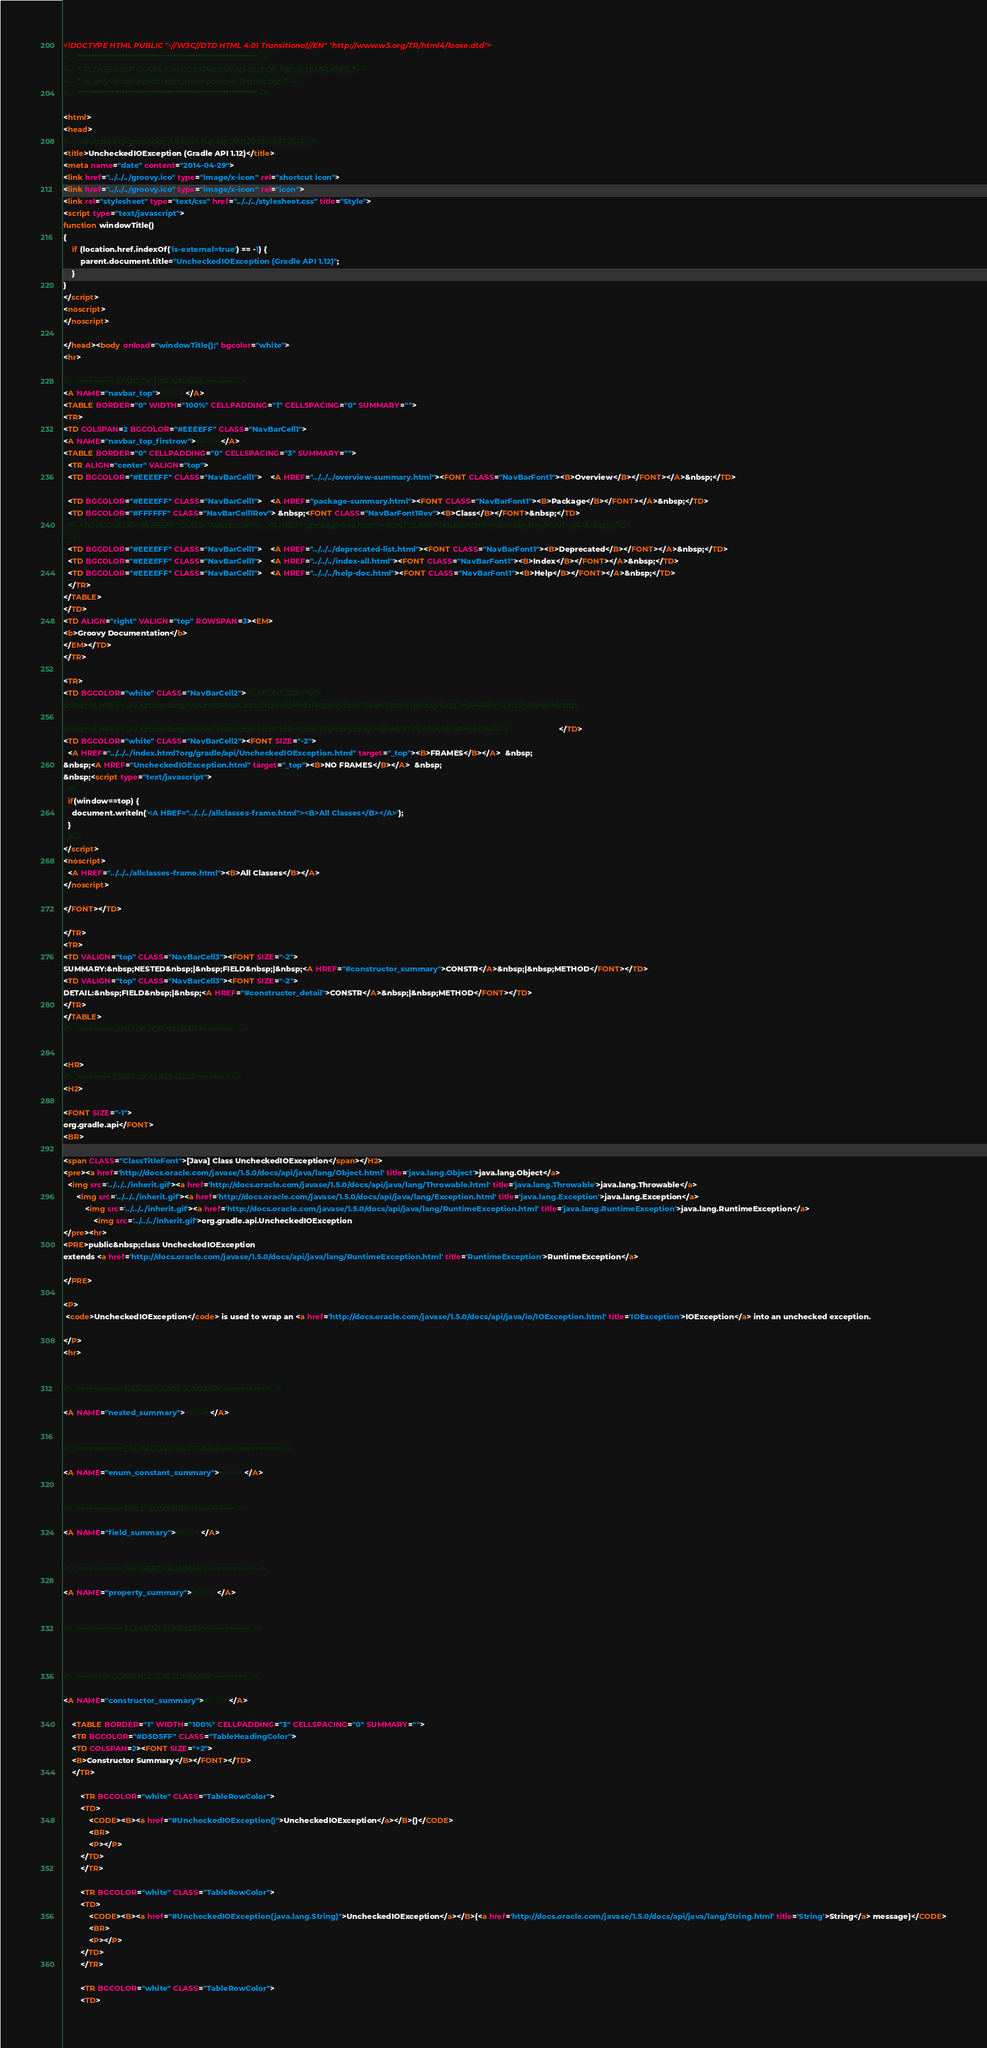<code> <loc_0><loc_0><loc_500><loc_500><_HTML_><!DOCTYPE HTML PUBLIC "-//W3C//DTD HTML 4.01 Transitional//EN" "http://www.w3.org/TR/html4/loose.dtd">
<!-- **************************************************************** -->
<!-- *  PLEASE KEEP COMPLICATED EXPRESSIONS OUT OF THESE TEMPLATES, * -->
<!-- *  i.e. only iterate & print data where possible. Thanks, Jez. * -->
<!-- **************************************************************** -->

<html>
<head>
<!-- Generated by groovydoc (1.8.6) on Tue Apr 29 11:29:28 CEST 2014 -->
<title>UncheckedIOException (Gradle API 1.12)</title>
<meta name="date" content="2014-04-29">
<link href="../../../groovy.ico" type="image/x-icon" rel="shortcut icon">
<link href="../../../groovy.ico" type="image/x-icon" rel="icon">
<link rel="stylesheet" type="text/css" href="../../../stylesheet.css" title="Style">
<script type="text/javascript">
function windowTitle()
{
    if (location.href.indexOf('is-external=true') == -1) {
        parent.document.title="UncheckedIOException (Gradle API 1.12)";
    }
}
</script>
<noscript>
</noscript>

</head><body onload="windowTitle();" bgcolor="white">
<hr>

<!-- ========= START OF TOP NAVBAR ======= -->
<A NAME="navbar_top"><!-- --></A>
<TABLE BORDER="0" WIDTH="100%" CELLPADDING="1" CELLSPACING="0" SUMMARY="">
<TR>
<TD COLSPAN=2 BGCOLOR="#EEEEFF" CLASS="NavBarCell1">
<A NAME="navbar_top_firstrow"><!-- --></A>
<TABLE BORDER="0" CELLPADDING="0" CELLSPACING="3" SUMMARY="">
  <TR ALIGN="center" VALIGN="top">
  <TD BGCOLOR="#EEEEFF" CLASS="NavBarCell1">    <A HREF="../../../overview-summary.html"><FONT CLASS="NavBarFont1"><B>Overview</B></FONT></A>&nbsp;</TD>

  <TD BGCOLOR="#EEEEFF" CLASS="NavBarCell1">    <A HREF="package-summary.html"><FONT CLASS="NavBarFont1"><B>Package</B></FONT></A>&nbsp;</TD>
  <TD BGCOLOR="#FFFFFF" CLASS="NavBarCell1Rev"> &nbsp;<FONT CLASS="NavBarFont1Rev"><B>Class</B></FONT>&nbsp;</TD>
  <!--<TD BGCOLOR="#EEEEFF" CLASS="NavBarCell1">    <A HREF="package-tree.html"><FONT CLASS="NavBarFont1"><B>Tree</B></FONT></A>&nbsp;</TD>
  -->
  <TD BGCOLOR="#EEEEFF" CLASS="NavBarCell1">    <A HREF="../../../deprecated-list.html"><FONT CLASS="NavBarFont1"><B>Deprecated</B></FONT></A>&nbsp;</TD>
  <TD BGCOLOR="#EEEEFF" CLASS="NavBarCell1">    <A HREF="../../../index-all.html"><FONT CLASS="NavBarFont1"><B>Index</B></FONT></A>&nbsp;</TD>
  <TD BGCOLOR="#EEEEFF" CLASS="NavBarCell1">    <A HREF="../../../help-doc.html"><FONT CLASS="NavBarFont1"><B>Help</B></FONT></A>&nbsp;</TD>
  </TR>
</TABLE>
</TD>
<TD ALIGN="right" VALIGN="top" ROWSPAN=3><EM>
<b>Groovy Documentation</b>
</EM></TD>
</TR>

<TR>
<TD BGCOLOR="white" CLASS="NavBarCell2"><!--<FONT SIZE="-2">
&nbsp;<A HREF="../../../groovy/lang/ExpandoMetaClass.ExpandoMetaProperty.html" title="class in groovy.lang"><B>PREV CLASS</B></A>&nbsp;

&nbsp;<A HREF="../../../groovy/lang/GroovyClassLoader.html" title="class in groovy.lang"><B>NEXT CLASS</B></A></FONT>--></TD>
<TD BGCOLOR="white" CLASS="NavBarCell2"><FONT SIZE="-2">
  <A HREF="../../../index.html?org/gradle/api/UncheckedIOException.html" target="_top"><B>FRAMES</B></A>  &nbsp;
&nbsp;<A HREF="UncheckedIOException.html" target="_top"><B>NO FRAMES</B></A>  &nbsp;
&nbsp;<script type="text/javascript">
  <!--
  if(window==top) {
    document.writeln('<A HREF="../../../allclasses-frame.html"><B>All Classes</B></A>');
  }
  //-->
</script>
<noscript>
  <A HREF="../../../allclasses-frame.html"><B>All Classes</B></A>
</noscript>

</FONT></TD>

</TR>
<TR>
<TD VALIGN="top" CLASS="NavBarCell3"><FONT SIZE="-2">
SUMMARY:&nbsp;NESTED&nbsp;|&nbsp;FIELD&nbsp;|&nbsp;<A HREF="#constructor_summary">CONSTR</A>&nbsp;|&nbsp;METHOD</FONT></TD>
<TD VALIGN="top" CLASS="NavBarCell3"><FONT SIZE="-2">
DETAIL:&nbsp;FIELD&nbsp;|&nbsp;<A HREF="#constructor_detail">CONSTR</A>&nbsp;|&nbsp;METHOD</FONT></TD>
</TR>
</TABLE>
<!-- ========= END OF TOP NAVBAR ========= -->


<HR>
<!-- ======== START OF CLASS DATA ======== -->
<H2>

<FONT SIZE="-1">
org.gradle.api</FONT>
<BR>

<span CLASS="ClassTitleFont">[Java] Class UncheckedIOException</span></H2>
<pre><a href='http://docs.oracle.com/javase/1.5.0/docs/api/java/lang/Object.html' title='java.lang.Object'>java.lang.Object</a>
  <img src='../../../inherit.gif'><a href='http://docs.oracle.com/javase/1.5.0/docs/api/java/lang/Throwable.html' title='java.lang.Throwable'>java.lang.Throwable</a>
      <img src='../../../inherit.gif'><a href='http://docs.oracle.com/javase/1.5.0/docs/api/java/lang/Exception.html' title='java.lang.Exception'>java.lang.Exception</a>
          <img src='../../../inherit.gif'><a href='http://docs.oracle.com/javase/1.5.0/docs/api/java/lang/RuntimeException.html' title='java.lang.RuntimeException'>java.lang.RuntimeException</a>
              <img src='../../../inherit.gif'>org.gradle.api.UncheckedIOException
</pre><hr>
<PRE>public&nbsp;class UncheckedIOException
extends <a href='http://docs.oracle.com/javase/1.5.0/docs/api/java/lang/RuntimeException.html' title='RuntimeException'>RuntimeException</a>

</PRE>

<P>
 <code>UncheckedIOException</code> is used to wrap an <a href='http://docs.oracle.com/javase/1.5.0/docs/api/java/io/IOException.html' title='IOException'>IOException</a> into an unchecked exception.
 
</P>
<hr>


<!-- =========== NESTED CLASS SUMMARY =========== -->

<A NAME="nested_summary"><!-- --></A>


<!-- =========== ENUM CONSTANT SUMMARY =========== -->

<A NAME="enum_constant_summary"><!-- --></A>


<!-- =========== FIELD SUMMARY =========== -->

<A NAME="field_summary"><!-- --></A>


<!-- =========== PROPERTY SUMMARY =========== -->

<A NAME="property_summary"><!-- --></A>


<!-- =========== ELEMENT SUMMARY =========== -->



<!-- ======== CONSTRUCTOR SUMMARY ======== -->

<A NAME="constructor_summary"><!-- --></A>

    <TABLE BORDER="1" WIDTH="100%" CELLPADDING="3" CELLSPACING="0" SUMMARY="">
    <TR BGCOLOR="#D5D5FF" CLASS="TableHeadingColor">
    <TD COLSPAN=2><FONT SIZE="+2">
    <B>Constructor Summary</B></FONT></TD>
    </TR>
    
        <TR BGCOLOR="white" CLASS="TableRowColor">
        <TD>
            <CODE><B><a href="#UncheckedIOException()">UncheckedIOException</a></B>()</CODE>
            <BR>
            <P></P>
        </TD>
        </TR>
    
        <TR BGCOLOR="white" CLASS="TableRowColor">
        <TD>
            <CODE><B><a href="#UncheckedIOException(java.lang.String)">UncheckedIOException</a></B>(<a href='http://docs.oracle.com/javase/1.5.0/docs/api/java/lang/String.html' title='String'>String</a> message)</CODE>
            <BR>
            <P></P>
        </TD>
        </TR>
    
        <TR BGCOLOR="white" CLASS="TableRowColor">
        <TD></code> 